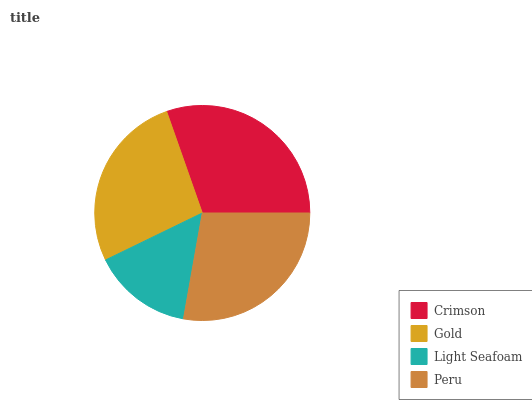Is Light Seafoam the minimum?
Answer yes or no. Yes. Is Crimson the maximum?
Answer yes or no. Yes. Is Gold the minimum?
Answer yes or no. No. Is Gold the maximum?
Answer yes or no. No. Is Crimson greater than Gold?
Answer yes or no. Yes. Is Gold less than Crimson?
Answer yes or no. Yes. Is Gold greater than Crimson?
Answer yes or no. No. Is Crimson less than Gold?
Answer yes or no. No. Is Peru the high median?
Answer yes or no. Yes. Is Gold the low median?
Answer yes or no. Yes. Is Gold the high median?
Answer yes or no. No. Is Light Seafoam the low median?
Answer yes or no. No. 